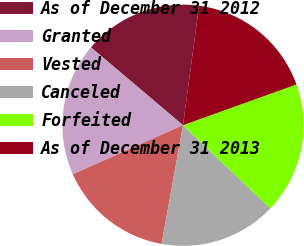Convert chart. <chart><loc_0><loc_0><loc_500><loc_500><pie_chart><fcel>As of December 31 2012<fcel>Granted<fcel>Vested<fcel>Canceled<fcel>Forfeited<fcel>As of December 31 2013<nl><fcel>15.95%<fcel>17.84%<fcel>15.49%<fcel>15.72%<fcel>17.61%<fcel>17.38%<nl></chart> 